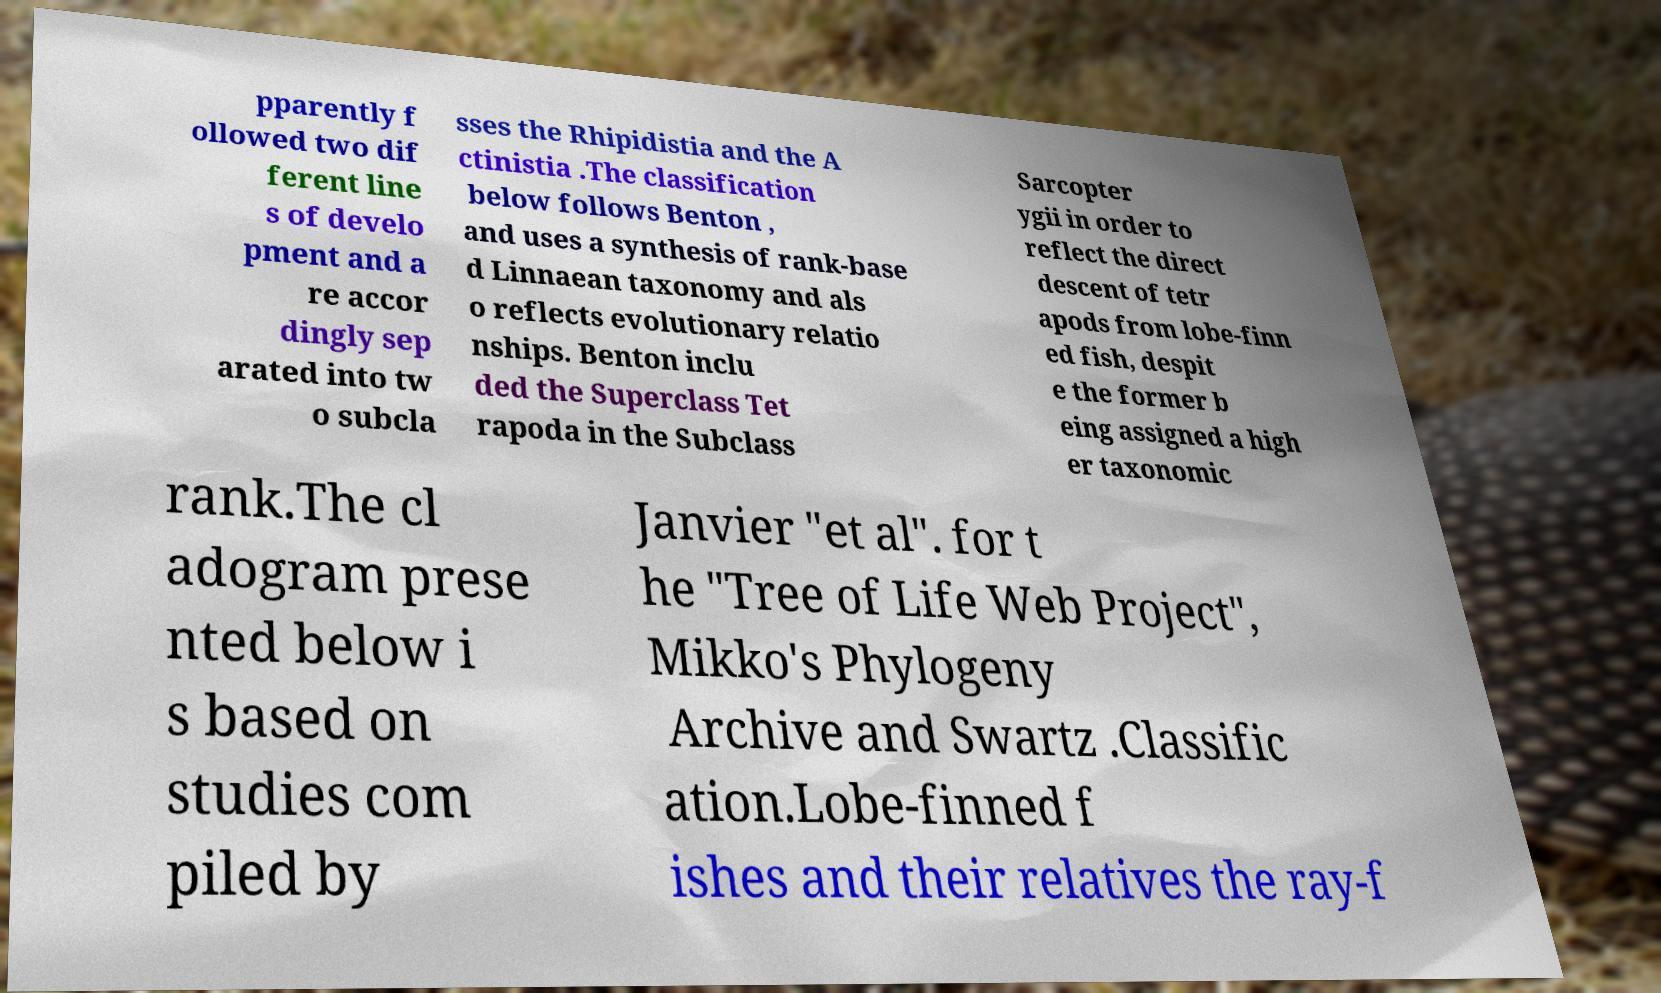Could you extract and type out the text from this image? pparently f ollowed two dif ferent line s of develo pment and a re accor dingly sep arated into tw o subcla sses the Rhipidistia and the A ctinistia .The classification below follows Benton , and uses a synthesis of rank-base d Linnaean taxonomy and als o reflects evolutionary relatio nships. Benton inclu ded the Superclass Tet rapoda in the Subclass Sarcopter ygii in order to reflect the direct descent of tetr apods from lobe-finn ed fish, despit e the former b eing assigned a high er taxonomic rank.The cl adogram prese nted below i s based on studies com piled by Janvier "et al". for t he "Tree of Life Web Project", Mikko's Phylogeny Archive and Swartz .Classific ation.Lobe-finned f ishes and their relatives the ray-f 